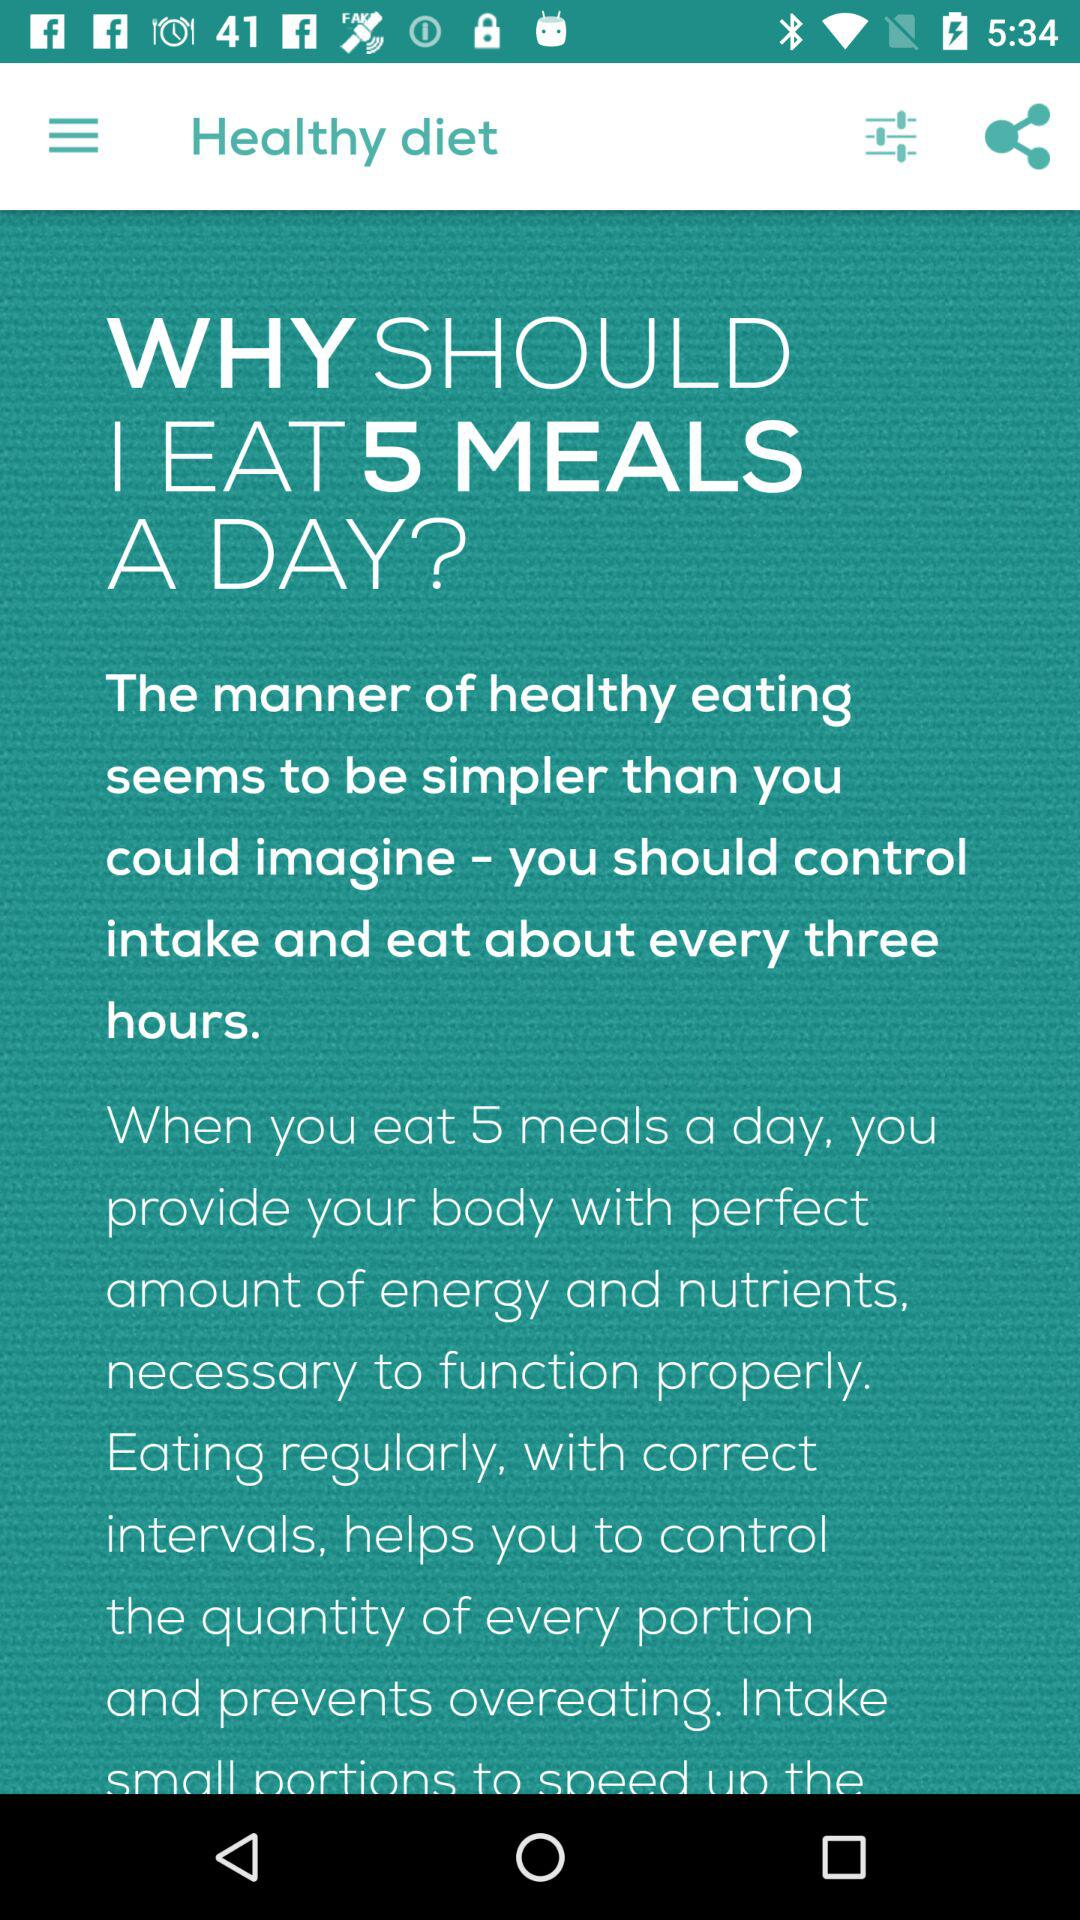How many meals should be eaten in a day? We should eat five meals a day. 